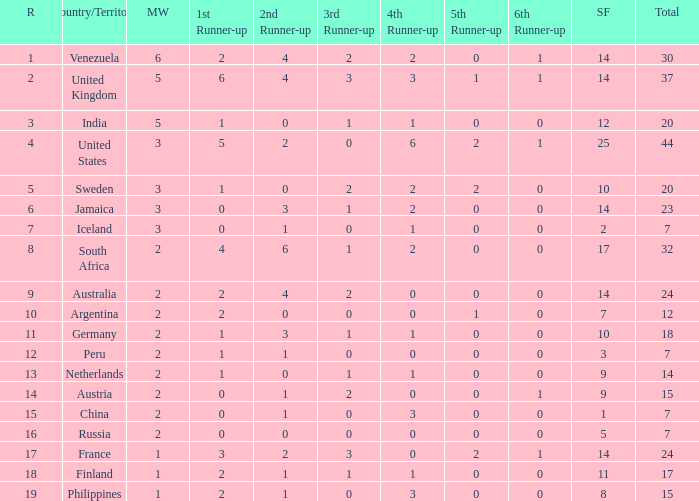Could you parse the entire table? {'header': ['R', 'Country/Territory', 'MW', '1st Runner-up', '2nd Runner-up', '3rd Runner-up', '4th Runner-up', '5th Runner-up', '6th Runner-up', 'SF', 'Total'], 'rows': [['1', 'Venezuela', '6', '2', '4', '2', '2', '0', '1', '14', '30'], ['2', 'United Kingdom', '5', '6', '4', '3', '3', '1', '1', '14', '37'], ['3', 'India', '5', '1', '0', '1', '1', '0', '0', '12', '20'], ['4', 'United States', '3', '5', '2', '0', '6', '2', '1', '25', '44'], ['5', 'Sweden', '3', '1', '0', '2', '2', '2', '0', '10', '20'], ['6', 'Jamaica', '3', '0', '3', '1', '2', '0', '0', '14', '23'], ['7', 'Iceland', '3', '0', '1', '0', '1', '0', '0', '2', '7'], ['8', 'South Africa', '2', '4', '6', '1', '2', '0', '0', '17', '32'], ['9', 'Australia', '2', '2', '4', '2', '0', '0', '0', '14', '24'], ['10', 'Argentina', '2', '2', '0', '0', '0', '1', '0', '7', '12'], ['11', 'Germany', '2', '1', '3', '1', '1', '0', '0', '10', '18'], ['12', 'Peru', '2', '1', '1', '0', '0', '0', '0', '3', '7'], ['13', 'Netherlands', '2', '1', '0', '1', '1', '0', '0', '9', '14'], ['14', 'Austria', '2', '0', '1', '2', '0', '0', '1', '9', '15'], ['15', 'China', '2', '0', '1', '0', '3', '0', '0', '1', '7'], ['16', 'Russia', '2', '0', '0', '0', '0', '0', '0', '5', '7'], ['17', 'France', '1', '3', '2', '3', '0', '2', '1', '14', '24'], ['18', 'Finland', '1', '2', '1', '1', '1', '0', '0', '11', '17'], ['19', 'Philippines', '1', '2', '1', '0', '3', '0', '0', '8', '15']]} What is Iceland's total? 1.0. 